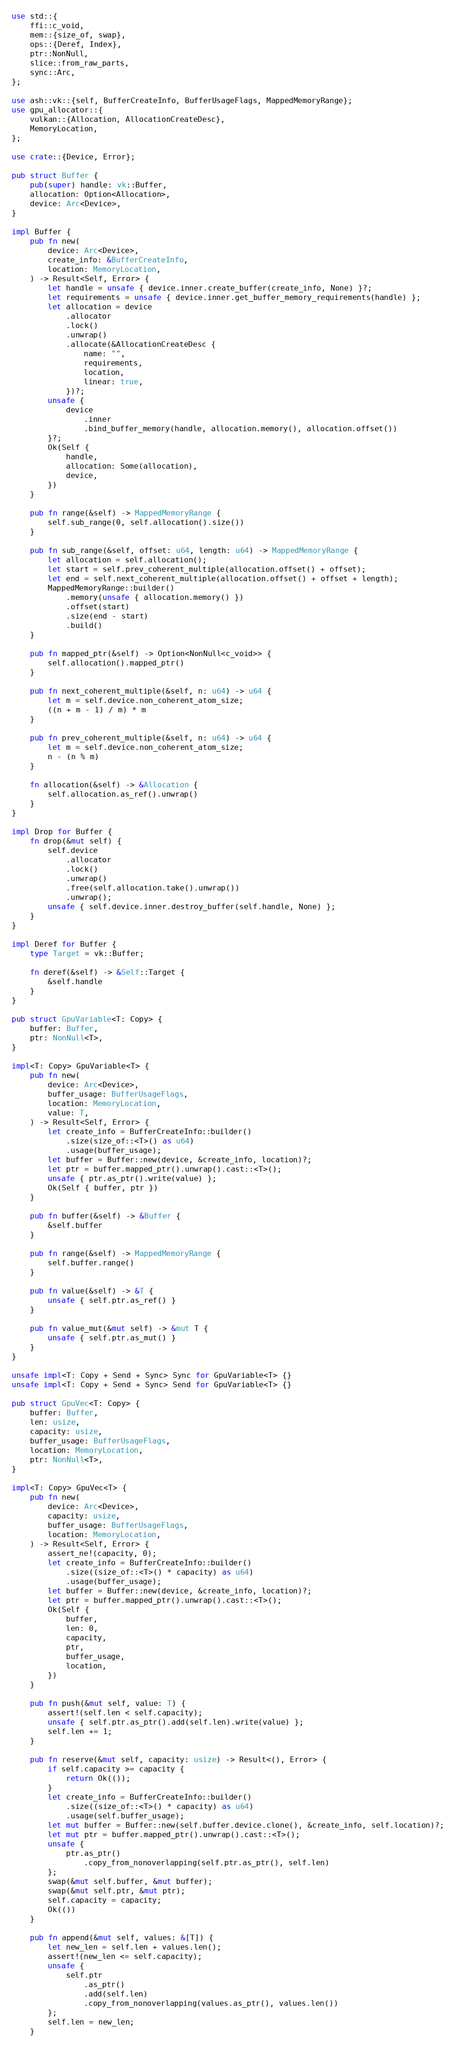Convert code to text. <code><loc_0><loc_0><loc_500><loc_500><_Rust_>use std::{
    ffi::c_void,
    mem::{size_of, swap},
    ops::{Deref, Index},
    ptr::NonNull,
    slice::from_raw_parts,
    sync::Arc,
};

use ash::vk::{self, BufferCreateInfo, BufferUsageFlags, MappedMemoryRange};
use gpu_allocator::{
    vulkan::{Allocation, AllocationCreateDesc},
    MemoryLocation,
};

use crate::{Device, Error};

pub struct Buffer {
    pub(super) handle: vk::Buffer,
    allocation: Option<Allocation>,
    device: Arc<Device>,
}

impl Buffer {
    pub fn new(
        device: Arc<Device>,
        create_info: &BufferCreateInfo,
        location: MemoryLocation,
    ) -> Result<Self, Error> {
        let handle = unsafe { device.inner.create_buffer(create_info, None) }?;
        let requirements = unsafe { device.inner.get_buffer_memory_requirements(handle) };
        let allocation = device
            .allocator
            .lock()
            .unwrap()
            .allocate(&AllocationCreateDesc {
                name: "",
                requirements,
                location,
                linear: true,
            })?;
        unsafe {
            device
                .inner
                .bind_buffer_memory(handle, allocation.memory(), allocation.offset())
        }?;
        Ok(Self {
            handle,
            allocation: Some(allocation),
            device,
        })
    }

    pub fn range(&self) -> MappedMemoryRange {
        self.sub_range(0, self.allocation().size())
    }

    pub fn sub_range(&self, offset: u64, length: u64) -> MappedMemoryRange {
        let allocation = self.allocation();
        let start = self.prev_coherent_multiple(allocation.offset() + offset);
        let end = self.next_coherent_multiple(allocation.offset() + offset + length);
        MappedMemoryRange::builder()
            .memory(unsafe { allocation.memory() })
            .offset(start)
            .size(end - start)
            .build()
    }

    pub fn mapped_ptr(&self) -> Option<NonNull<c_void>> {
        self.allocation().mapped_ptr()
    }

    pub fn next_coherent_multiple(&self, n: u64) -> u64 {
        let m = self.device.non_coherent_atom_size;
        ((n + m - 1) / m) * m
    }

    pub fn prev_coherent_multiple(&self, n: u64) -> u64 {
        let m = self.device.non_coherent_atom_size;
        n - (n % m)
    }

    fn allocation(&self) -> &Allocation {
        self.allocation.as_ref().unwrap()
    }
}

impl Drop for Buffer {
    fn drop(&mut self) {
        self.device
            .allocator
            .lock()
            .unwrap()
            .free(self.allocation.take().unwrap())
            .unwrap();
        unsafe { self.device.inner.destroy_buffer(self.handle, None) };
    }
}

impl Deref for Buffer {
    type Target = vk::Buffer;

    fn deref(&self) -> &Self::Target {
        &self.handle
    }
}

pub struct GpuVariable<T: Copy> {
    buffer: Buffer,
    ptr: NonNull<T>,
}

impl<T: Copy> GpuVariable<T> {
    pub fn new(
        device: Arc<Device>,
        buffer_usage: BufferUsageFlags,
        location: MemoryLocation,
        value: T,
    ) -> Result<Self, Error> {
        let create_info = BufferCreateInfo::builder()
            .size(size_of::<T>() as u64)
            .usage(buffer_usage);
        let buffer = Buffer::new(device, &create_info, location)?;
        let ptr = buffer.mapped_ptr().unwrap().cast::<T>();
        unsafe { ptr.as_ptr().write(value) };
        Ok(Self { buffer, ptr })
    }

    pub fn buffer(&self) -> &Buffer {
        &self.buffer
    }

    pub fn range(&self) -> MappedMemoryRange {
        self.buffer.range()
    }

    pub fn value(&self) -> &T {
        unsafe { self.ptr.as_ref() }
    }

    pub fn value_mut(&mut self) -> &mut T {
        unsafe { self.ptr.as_mut() }
    }
}

unsafe impl<T: Copy + Send + Sync> Sync for GpuVariable<T> {}
unsafe impl<T: Copy + Send + Sync> Send for GpuVariable<T> {}

pub struct GpuVec<T: Copy> {
    buffer: Buffer,
    len: usize,
    capacity: usize,
    buffer_usage: BufferUsageFlags,
    location: MemoryLocation,
    ptr: NonNull<T>,
}

impl<T: Copy> GpuVec<T> {
    pub fn new(
        device: Arc<Device>,
        capacity: usize,
        buffer_usage: BufferUsageFlags,
        location: MemoryLocation,
    ) -> Result<Self, Error> {
        assert_ne!(capacity, 0);
        let create_info = BufferCreateInfo::builder()
            .size((size_of::<T>() * capacity) as u64)
            .usage(buffer_usage);
        let buffer = Buffer::new(device, &create_info, location)?;
        let ptr = buffer.mapped_ptr().unwrap().cast::<T>();
        Ok(Self {
            buffer,
            len: 0,
            capacity,
            ptr,
            buffer_usage,
            location,
        })
    }

    pub fn push(&mut self, value: T) {
        assert!(self.len < self.capacity);
        unsafe { self.ptr.as_ptr().add(self.len).write(value) };
        self.len += 1;
    }

    pub fn reserve(&mut self, capacity: usize) -> Result<(), Error> {
        if self.capacity >= capacity {
            return Ok(());
        }
        let create_info = BufferCreateInfo::builder()
            .size((size_of::<T>() * capacity) as u64)
            .usage(self.buffer_usage);
        let mut buffer = Buffer::new(self.buffer.device.clone(), &create_info, self.location)?;
        let mut ptr = buffer.mapped_ptr().unwrap().cast::<T>();
        unsafe {
            ptr.as_ptr()
                .copy_from_nonoverlapping(self.ptr.as_ptr(), self.len)
        };
        swap(&mut self.buffer, &mut buffer);
        swap(&mut self.ptr, &mut ptr);
        self.capacity = capacity;
        Ok(())
    }

    pub fn append(&mut self, values: &[T]) {
        let new_len = self.len + values.len();
        assert!(new_len <= self.capacity);
        unsafe {
            self.ptr
                .as_ptr()
                .add(self.len)
                .copy_from_nonoverlapping(values.as_ptr(), values.len())
        };
        self.len = new_len;
    }
</code> 